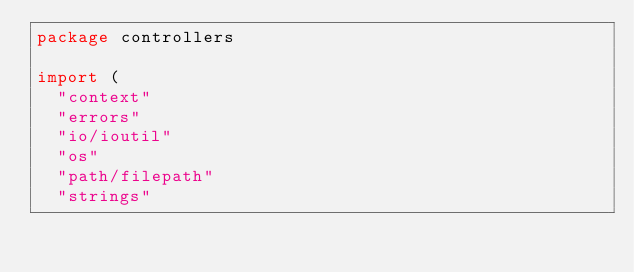Convert code to text. <code><loc_0><loc_0><loc_500><loc_500><_Go_>package controllers

import (
	"context"
	"errors"
	"io/ioutil"
	"os"
	"path/filepath"
	"strings"
</code> 